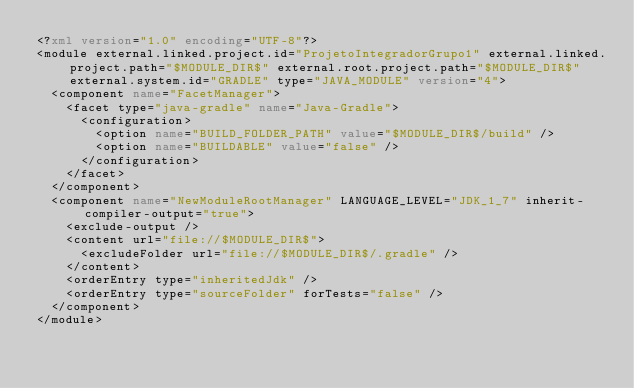<code> <loc_0><loc_0><loc_500><loc_500><_XML_><?xml version="1.0" encoding="UTF-8"?>
<module external.linked.project.id="ProjetoIntegradorGrupo1" external.linked.project.path="$MODULE_DIR$" external.root.project.path="$MODULE_DIR$" external.system.id="GRADLE" type="JAVA_MODULE" version="4">
  <component name="FacetManager">
    <facet type="java-gradle" name="Java-Gradle">
      <configuration>
        <option name="BUILD_FOLDER_PATH" value="$MODULE_DIR$/build" />
        <option name="BUILDABLE" value="false" />
      </configuration>
    </facet>
  </component>
  <component name="NewModuleRootManager" LANGUAGE_LEVEL="JDK_1_7" inherit-compiler-output="true">
    <exclude-output />
    <content url="file://$MODULE_DIR$">
      <excludeFolder url="file://$MODULE_DIR$/.gradle" />
    </content>
    <orderEntry type="inheritedJdk" />
    <orderEntry type="sourceFolder" forTests="false" />
  </component>
</module></code> 